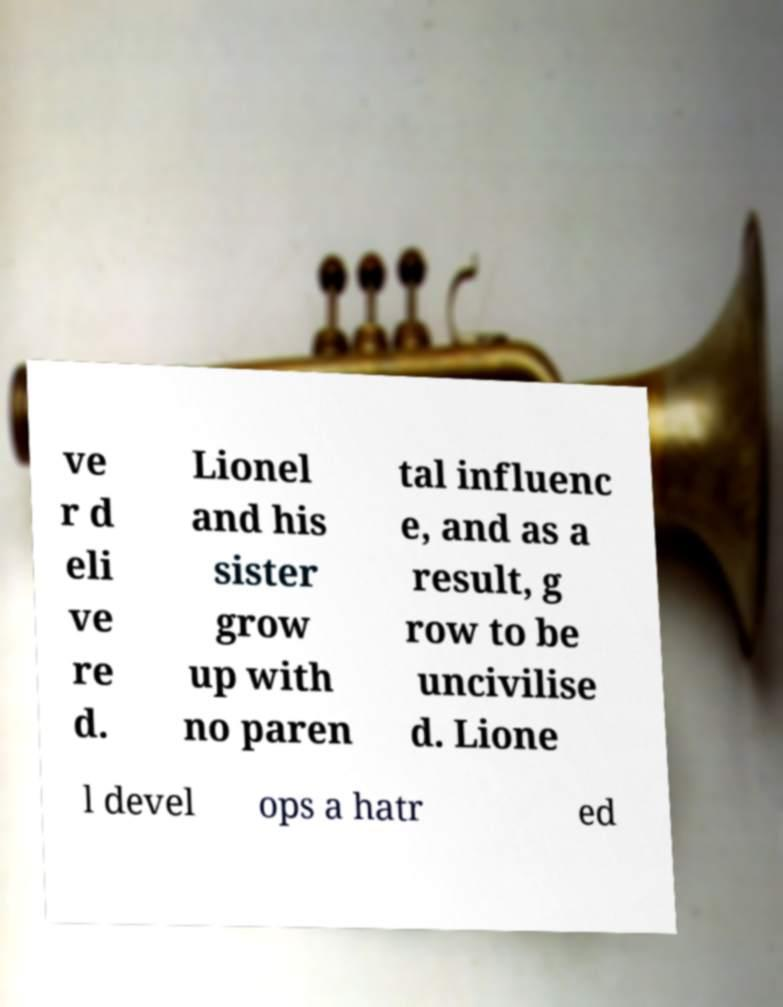Could you extract and type out the text from this image? ve r d eli ve re d. Lionel and his sister grow up with no paren tal influenc e, and as a result, g row to be uncivilise d. Lione l devel ops a hatr ed 